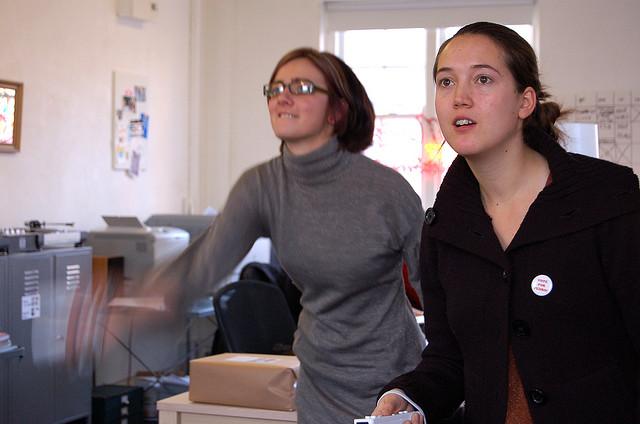Is this mother and child?
Short answer required. No. Is everybody pictured a woman?
Keep it brief. Yes. Are these people working in a typical office?
Quick response, please. No. Why is the woman smiling?
Write a very short answer. Playing. Are the women playing a video game?
Keep it brief. Yes. Is there a man in the image?
Answer briefly. No. What sort of room are they in?
Quick response, please. Office. Are both women smiling?
Concise answer only. No. Is one of these women wearing glasses?
Short answer required. Yes. 